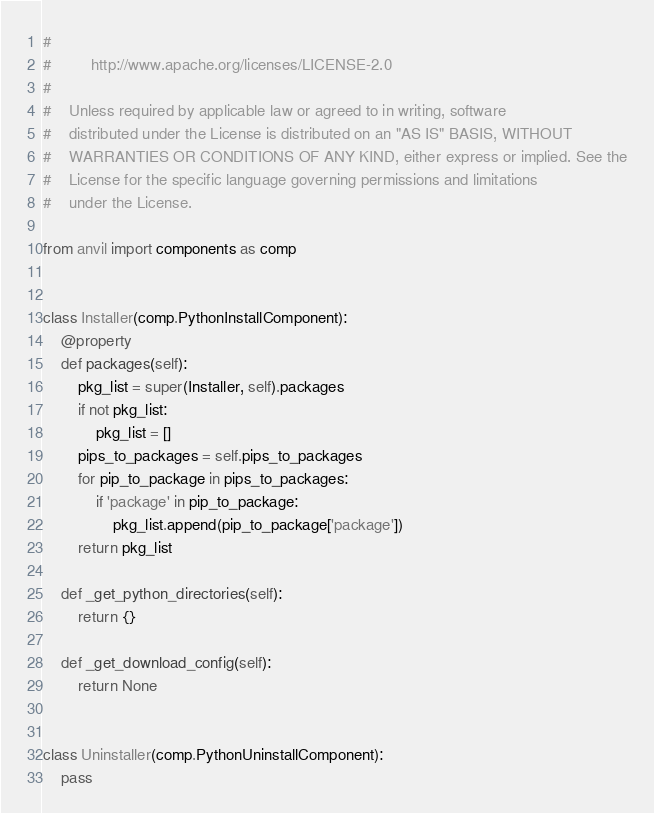Convert code to text. <code><loc_0><loc_0><loc_500><loc_500><_Python_>#
#         http://www.apache.org/licenses/LICENSE-2.0
#
#    Unless required by applicable law or agreed to in writing, software
#    distributed under the License is distributed on an "AS IS" BASIS, WITHOUT
#    WARRANTIES OR CONDITIONS OF ANY KIND, either express or implied. See the
#    License for the specific language governing permissions and limitations
#    under the License.

from anvil import components as comp


class Installer(comp.PythonInstallComponent):
    @property
    def packages(self):
        pkg_list = super(Installer, self).packages
        if not pkg_list:
            pkg_list = []
        pips_to_packages = self.pips_to_packages
        for pip_to_package in pips_to_packages:
            if 'package' in pip_to_package:
                pkg_list.append(pip_to_package['package'])
        return pkg_list

    def _get_python_directories(self):
        return {}

    def _get_download_config(self):
        return None


class Uninstaller(comp.PythonUninstallComponent):
    pass
</code> 